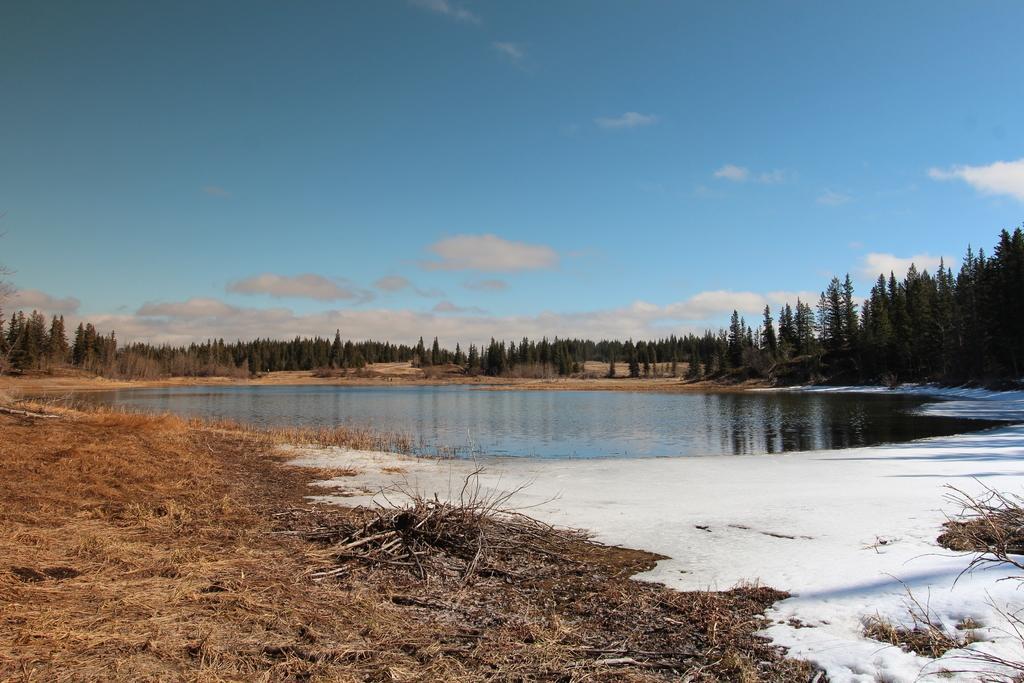Describe this image in one or two sentences. In this image there is a lake. Background there are trees on the grassland. Top of the image there is sky with some clouds. 